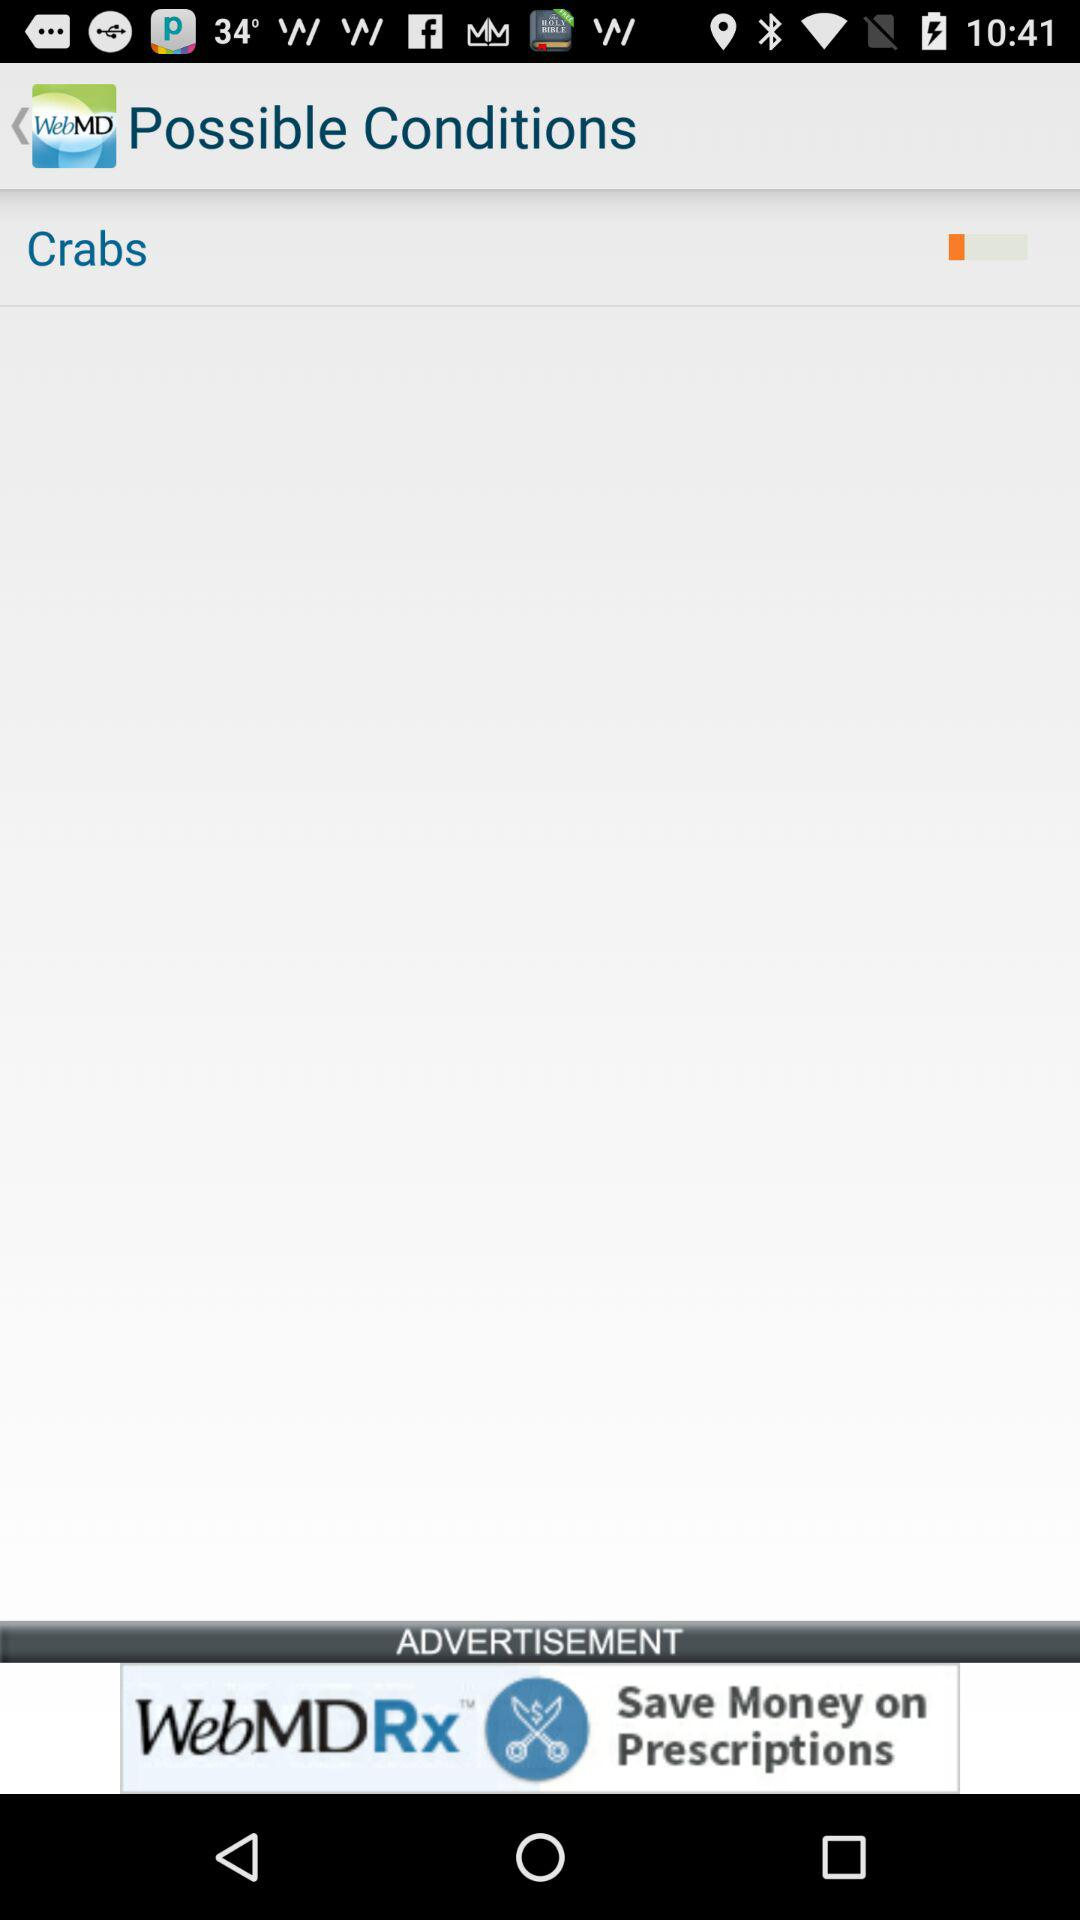What's the status of "Crabs"? The status of "Crabs" is "off". 